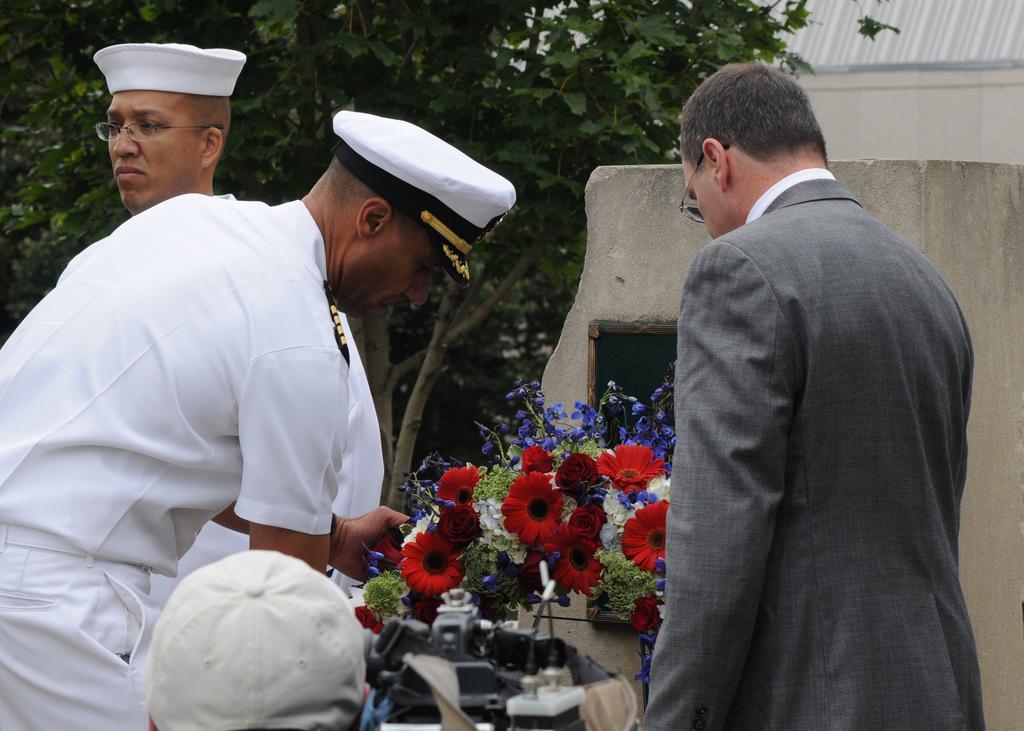How would you summarize this image in a sentence or two? In this image we can see few persons, plants with flowers, device and at the bottom there is a cap on a person´s head. In the background we can see walls and trees. 